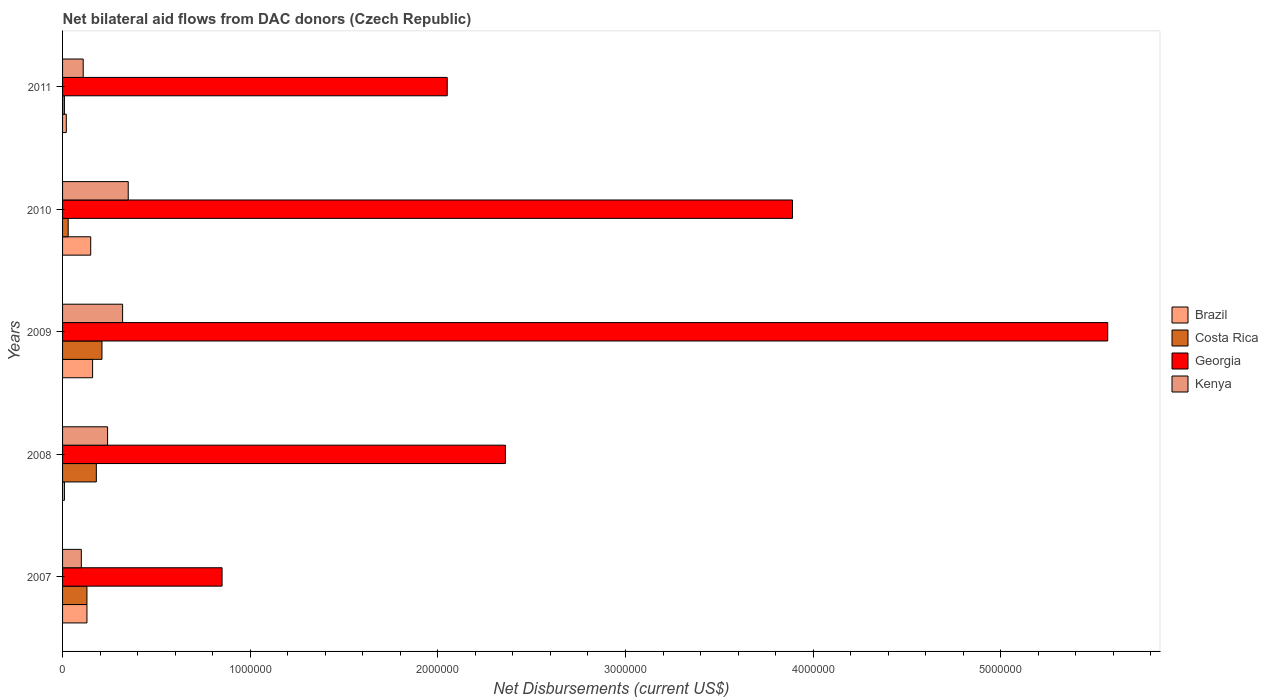Are the number of bars per tick equal to the number of legend labels?
Provide a short and direct response. Yes. Are the number of bars on each tick of the Y-axis equal?
Provide a succinct answer. Yes. How many bars are there on the 2nd tick from the top?
Offer a very short reply. 4. How many bars are there on the 3rd tick from the bottom?
Give a very brief answer. 4. What is the label of the 1st group of bars from the top?
Provide a succinct answer. 2011. In how many cases, is the number of bars for a given year not equal to the number of legend labels?
Your answer should be compact. 0. What is the net bilateral aid flows in Costa Rica in 2010?
Offer a very short reply. 3.00e+04. Across all years, what is the maximum net bilateral aid flows in Costa Rica?
Keep it short and to the point. 2.10e+05. Across all years, what is the minimum net bilateral aid flows in Kenya?
Your response must be concise. 1.00e+05. In which year was the net bilateral aid flows in Costa Rica maximum?
Your answer should be compact. 2009. In which year was the net bilateral aid flows in Georgia minimum?
Ensure brevity in your answer.  2007. What is the total net bilateral aid flows in Georgia in the graph?
Give a very brief answer. 1.47e+07. What is the difference between the net bilateral aid flows in Costa Rica in 2010 and the net bilateral aid flows in Georgia in 2009?
Offer a terse response. -5.54e+06. What is the average net bilateral aid flows in Brazil per year?
Provide a succinct answer. 9.40e+04. In how many years, is the net bilateral aid flows in Georgia greater than 1400000 US$?
Provide a short and direct response. 4. What is the ratio of the net bilateral aid flows in Kenya in 2007 to that in 2010?
Give a very brief answer. 0.29. Is the net bilateral aid flows in Costa Rica in 2007 less than that in 2009?
Ensure brevity in your answer.  Yes. What is the difference between the highest and the second highest net bilateral aid flows in Costa Rica?
Offer a terse response. 3.00e+04. What is the difference between the highest and the lowest net bilateral aid flows in Kenya?
Offer a terse response. 2.50e+05. Is the sum of the net bilateral aid flows in Kenya in 2008 and 2009 greater than the maximum net bilateral aid flows in Brazil across all years?
Your answer should be compact. Yes. Is it the case that in every year, the sum of the net bilateral aid flows in Costa Rica and net bilateral aid flows in Georgia is greater than the sum of net bilateral aid flows in Brazil and net bilateral aid flows in Kenya?
Give a very brief answer. Yes. Is it the case that in every year, the sum of the net bilateral aid flows in Brazil and net bilateral aid flows in Georgia is greater than the net bilateral aid flows in Costa Rica?
Offer a terse response. Yes. How many years are there in the graph?
Offer a very short reply. 5. Does the graph contain any zero values?
Ensure brevity in your answer.  No. Where does the legend appear in the graph?
Give a very brief answer. Center right. How many legend labels are there?
Provide a short and direct response. 4. How are the legend labels stacked?
Your answer should be compact. Vertical. What is the title of the graph?
Provide a short and direct response. Net bilateral aid flows from DAC donors (Czech Republic). What is the label or title of the X-axis?
Provide a short and direct response. Net Disbursements (current US$). What is the Net Disbursements (current US$) of Brazil in 2007?
Provide a short and direct response. 1.30e+05. What is the Net Disbursements (current US$) in Costa Rica in 2007?
Ensure brevity in your answer.  1.30e+05. What is the Net Disbursements (current US$) of Georgia in 2007?
Provide a short and direct response. 8.50e+05. What is the Net Disbursements (current US$) of Georgia in 2008?
Provide a short and direct response. 2.36e+06. What is the Net Disbursements (current US$) in Costa Rica in 2009?
Your answer should be very brief. 2.10e+05. What is the Net Disbursements (current US$) of Georgia in 2009?
Your answer should be compact. 5.57e+06. What is the Net Disbursements (current US$) in Kenya in 2009?
Ensure brevity in your answer.  3.20e+05. What is the Net Disbursements (current US$) of Georgia in 2010?
Provide a short and direct response. 3.89e+06. What is the Net Disbursements (current US$) in Georgia in 2011?
Provide a short and direct response. 2.05e+06. Across all years, what is the maximum Net Disbursements (current US$) of Costa Rica?
Your response must be concise. 2.10e+05. Across all years, what is the maximum Net Disbursements (current US$) of Georgia?
Provide a succinct answer. 5.57e+06. Across all years, what is the minimum Net Disbursements (current US$) in Georgia?
Offer a very short reply. 8.50e+05. Across all years, what is the minimum Net Disbursements (current US$) of Kenya?
Your response must be concise. 1.00e+05. What is the total Net Disbursements (current US$) of Brazil in the graph?
Ensure brevity in your answer.  4.70e+05. What is the total Net Disbursements (current US$) in Costa Rica in the graph?
Keep it short and to the point. 5.60e+05. What is the total Net Disbursements (current US$) of Georgia in the graph?
Provide a succinct answer. 1.47e+07. What is the total Net Disbursements (current US$) in Kenya in the graph?
Keep it short and to the point. 1.12e+06. What is the difference between the Net Disbursements (current US$) in Brazil in 2007 and that in 2008?
Offer a very short reply. 1.20e+05. What is the difference between the Net Disbursements (current US$) in Costa Rica in 2007 and that in 2008?
Your answer should be very brief. -5.00e+04. What is the difference between the Net Disbursements (current US$) of Georgia in 2007 and that in 2008?
Offer a very short reply. -1.51e+06. What is the difference between the Net Disbursements (current US$) of Kenya in 2007 and that in 2008?
Offer a very short reply. -1.40e+05. What is the difference between the Net Disbursements (current US$) in Brazil in 2007 and that in 2009?
Your response must be concise. -3.00e+04. What is the difference between the Net Disbursements (current US$) in Costa Rica in 2007 and that in 2009?
Your answer should be very brief. -8.00e+04. What is the difference between the Net Disbursements (current US$) in Georgia in 2007 and that in 2009?
Provide a short and direct response. -4.72e+06. What is the difference between the Net Disbursements (current US$) in Costa Rica in 2007 and that in 2010?
Give a very brief answer. 1.00e+05. What is the difference between the Net Disbursements (current US$) of Georgia in 2007 and that in 2010?
Your answer should be compact. -3.04e+06. What is the difference between the Net Disbursements (current US$) of Brazil in 2007 and that in 2011?
Your answer should be very brief. 1.10e+05. What is the difference between the Net Disbursements (current US$) of Costa Rica in 2007 and that in 2011?
Your answer should be very brief. 1.20e+05. What is the difference between the Net Disbursements (current US$) in Georgia in 2007 and that in 2011?
Offer a very short reply. -1.20e+06. What is the difference between the Net Disbursements (current US$) of Kenya in 2007 and that in 2011?
Make the answer very short. -10000. What is the difference between the Net Disbursements (current US$) of Brazil in 2008 and that in 2009?
Provide a short and direct response. -1.50e+05. What is the difference between the Net Disbursements (current US$) in Georgia in 2008 and that in 2009?
Provide a short and direct response. -3.21e+06. What is the difference between the Net Disbursements (current US$) of Brazil in 2008 and that in 2010?
Give a very brief answer. -1.40e+05. What is the difference between the Net Disbursements (current US$) in Costa Rica in 2008 and that in 2010?
Provide a short and direct response. 1.50e+05. What is the difference between the Net Disbursements (current US$) in Georgia in 2008 and that in 2010?
Your answer should be compact. -1.53e+06. What is the difference between the Net Disbursements (current US$) of Kenya in 2008 and that in 2010?
Offer a very short reply. -1.10e+05. What is the difference between the Net Disbursements (current US$) of Georgia in 2008 and that in 2011?
Offer a very short reply. 3.10e+05. What is the difference between the Net Disbursements (current US$) in Georgia in 2009 and that in 2010?
Provide a succinct answer. 1.68e+06. What is the difference between the Net Disbursements (current US$) in Brazil in 2009 and that in 2011?
Your answer should be compact. 1.40e+05. What is the difference between the Net Disbursements (current US$) of Georgia in 2009 and that in 2011?
Provide a short and direct response. 3.52e+06. What is the difference between the Net Disbursements (current US$) of Georgia in 2010 and that in 2011?
Your answer should be very brief. 1.84e+06. What is the difference between the Net Disbursements (current US$) of Brazil in 2007 and the Net Disbursements (current US$) of Costa Rica in 2008?
Ensure brevity in your answer.  -5.00e+04. What is the difference between the Net Disbursements (current US$) of Brazil in 2007 and the Net Disbursements (current US$) of Georgia in 2008?
Make the answer very short. -2.23e+06. What is the difference between the Net Disbursements (current US$) of Costa Rica in 2007 and the Net Disbursements (current US$) of Georgia in 2008?
Make the answer very short. -2.23e+06. What is the difference between the Net Disbursements (current US$) in Costa Rica in 2007 and the Net Disbursements (current US$) in Kenya in 2008?
Your answer should be very brief. -1.10e+05. What is the difference between the Net Disbursements (current US$) in Georgia in 2007 and the Net Disbursements (current US$) in Kenya in 2008?
Offer a terse response. 6.10e+05. What is the difference between the Net Disbursements (current US$) in Brazil in 2007 and the Net Disbursements (current US$) in Costa Rica in 2009?
Keep it short and to the point. -8.00e+04. What is the difference between the Net Disbursements (current US$) in Brazil in 2007 and the Net Disbursements (current US$) in Georgia in 2009?
Your response must be concise. -5.44e+06. What is the difference between the Net Disbursements (current US$) in Brazil in 2007 and the Net Disbursements (current US$) in Kenya in 2009?
Offer a terse response. -1.90e+05. What is the difference between the Net Disbursements (current US$) in Costa Rica in 2007 and the Net Disbursements (current US$) in Georgia in 2009?
Ensure brevity in your answer.  -5.44e+06. What is the difference between the Net Disbursements (current US$) of Costa Rica in 2007 and the Net Disbursements (current US$) of Kenya in 2009?
Ensure brevity in your answer.  -1.90e+05. What is the difference between the Net Disbursements (current US$) of Georgia in 2007 and the Net Disbursements (current US$) of Kenya in 2009?
Provide a short and direct response. 5.30e+05. What is the difference between the Net Disbursements (current US$) of Brazil in 2007 and the Net Disbursements (current US$) of Georgia in 2010?
Keep it short and to the point. -3.76e+06. What is the difference between the Net Disbursements (current US$) in Brazil in 2007 and the Net Disbursements (current US$) in Kenya in 2010?
Provide a short and direct response. -2.20e+05. What is the difference between the Net Disbursements (current US$) in Costa Rica in 2007 and the Net Disbursements (current US$) in Georgia in 2010?
Your answer should be very brief. -3.76e+06. What is the difference between the Net Disbursements (current US$) of Brazil in 2007 and the Net Disbursements (current US$) of Costa Rica in 2011?
Your answer should be very brief. 1.20e+05. What is the difference between the Net Disbursements (current US$) in Brazil in 2007 and the Net Disbursements (current US$) in Georgia in 2011?
Offer a very short reply. -1.92e+06. What is the difference between the Net Disbursements (current US$) in Brazil in 2007 and the Net Disbursements (current US$) in Kenya in 2011?
Ensure brevity in your answer.  2.00e+04. What is the difference between the Net Disbursements (current US$) of Costa Rica in 2007 and the Net Disbursements (current US$) of Georgia in 2011?
Your response must be concise. -1.92e+06. What is the difference between the Net Disbursements (current US$) in Costa Rica in 2007 and the Net Disbursements (current US$) in Kenya in 2011?
Provide a succinct answer. 2.00e+04. What is the difference between the Net Disbursements (current US$) in Georgia in 2007 and the Net Disbursements (current US$) in Kenya in 2011?
Ensure brevity in your answer.  7.40e+05. What is the difference between the Net Disbursements (current US$) of Brazil in 2008 and the Net Disbursements (current US$) of Costa Rica in 2009?
Offer a very short reply. -2.00e+05. What is the difference between the Net Disbursements (current US$) of Brazil in 2008 and the Net Disbursements (current US$) of Georgia in 2009?
Ensure brevity in your answer.  -5.56e+06. What is the difference between the Net Disbursements (current US$) of Brazil in 2008 and the Net Disbursements (current US$) of Kenya in 2009?
Your answer should be compact. -3.10e+05. What is the difference between the Net Disbursements (current US$) of Costa Rica in 2008 and the Net Disbursements (current US$) of Georgia in 2009?
Offer a terse response. -5.39e+06. What is the difference between the Net Disbursements (current US$) in Costa Rica in 2008 and the Net Disbursements (current US$) in Kenya in 2009?
Your answer should be compact. -1.40e+05. What is the difference between the Net Disbursements (current US$) of Georgia in 2008 and the Net Disbursements (current US$) of Kenya in 2009?
Provide a short and direct response. 2.04e+06. What is the difference between the Net Disbursements (current US$) of Brazil in 2008 and the Net Disbursements (current US$) of Costa Rica in 2010?
Your response must be concise. -2.00e+04. What is the difference between the Net Disbursements (current US$) of Brazil in 2008 and the Net Disbursements (current US$) of Georgia in 2010?
Offer a terse response. -3.88e+06. What is the difference between the Net Disbursements (current US$) in Costa Rica in 2008 and the Net Disbursements (current US$) in Georgia in 2010?
Your answer should be very brief. -3.71e+06. What is the difference between the Net Disbursements (current US$) of Costa Rica in 2008 and the Net Disbursements (current US$) of Kenya in 2010?
Ensure brevity in your answer.  -1.70e+05. What is the difference between the Net Disbursements (current US$) of Georgia in 2008 and the Net Disbursements (current US$) of Kenya in 2010?
Make the answer very short. 2.01e+06. What is the difference between the Net Disbursements (current US$) of Brazil in 2008 and the Net Disbursements (current US$) of Georgia in 2011?
Your response must be concise. -2.04e+06. What is the difference between the Net Disbursements (current US$) in Costa Rica in 2008 and the Net Disbursements (current US$) in Georgia in 2011?
Your response must be concise. -1.87e+06. What is the difference between the Net Disbursements (current US$) of Georgia in 2008 and the Net Disbursements (current US$) of Kenya in 2011?
Offer a terse response. 2.25e+06. What is the difference between the Net Disbursements (current US$) in Brazil in 2009 and the Net Disbursements (current US$) in Costa Rica in 2010?
Make the answer very short. 1.30e+05. What is the difference between the Net Disbursements (current US$) in Brazil in 2009 and the Net Disbursements (current US$) in Georgia in 2010?
Give a very brief answer. -3.73e+06. What is the difference between the Net Disbursements (current US$) in Costa Rica in 2009 and the Net Disbursements (current US$) in Georgia in 2010?
Provide a succinct answer. -3.68e+06. What is the difference between the Net Disbursements (current US$) in Georgia in 2009 and the Net Disbursements (current US$) in Kenya in 2010?
Ensure brevity in your answer.  5.22e+06. What is the difference between the Net Disbursements (current US$) of Brazil in 2009 and the Net Disbursements (current US$) of Costa Rica in 2011?
Keep it short and to the point. 1.50e+05. What is the difference between the Net Disbursements (current US$) of Brazil in 2009 and the Net Disbursements (current US$) of Georgia in 2011?
Offer a very short reply. -1.89e+06. What is the difference between the Net Disbursements (current US$) of Costa Rica in 2009 and the Net Disbursements (current US$) of Georgia in 2011?
Offer a very short reply. -1.84e+06. What is the difference between the Net Disbursements (current US$) of Costa Rica in 2009 and the Net Disbursements (current US$) of Kenya in 2011?
Offer a terse response. 1.00e+05. What is the difference between the Net Disbursements (current US$) of Georgia in 2009 and the Net Disbursements (current US$) of Kenya in 2011?
Provide a short and direct response. 5.46e+06. What is the difference between the Net Disbursements (current US$) in Brazil in 2010 and the Net Disbursements (current US$) in Costa Rica in 2011?
Give a very brief answer. 1.40e+05. What is the difference between the Net Disbursements (current US$) in Brazil in 2010 and the Net Disbursements (current US$) in Georgia in 2011?
Give a very brief answer. -1.90e+06. What is the difference between the Net Disbursements (current US$) in Costa Rica in 2010 and the Net Disbursements (current US$) in Georgia in 2011?
Give a very brief answer. -2.02e+06. What is the difference between the Net Disbursements (current US$) of Georgia in 2010 and the Net Disbursements (current US$) of Kenya in 2011?
Offer a terse response. 3.78e+06. What is the average Net Disbursements (current US$) in Brazil per year?
Your answer should be very brief. 9.40e+04. What is the average Net Disbursements (current US$) in Costa Rica per year?
Keep it short and to the point. 1.12e+05. What is the average Net Disbursements (current US$) in Georgia per year?
Provide a short and direct response. 2.94e+06. What is the average Net Disbursements (current US$) in Kenya per year?
Your answer should be very brief. 2.24e+05. In the year 2007, what is the difference between the Net Disbursements (current US$) in Brazil and Net Disbursements (current US$) in Costa Rica?
Provide a short and direct response. 0. In the year 2007, what is the difference between the Net Disbursements (current US$) in Brazil and Net Disbursements (current US$) in Georgia?
Offer a very short reply. -7.20e+05. In the year 2007, what is the difference between the Net Disbursements (current US$) in Costa Rica and Net Disbursements (current US$) in Georgia?
Ensure brevity in your answer.  -7.20e+05. In the year 2007, what is the difference between the Net Disbursements (current US$) of Georgia and Net Disbursements (current US$) of Kenya?
Offer a very short reply. 7.50e+05. In the year 2008, what is the difference between the Net Disbursements (current US$) in Brazil and Net Disbursements (current US$) in Georgia?
Offer a very short reply. -2.35e+06. In the year 2008, what is the difference between the Net Disbursements (current US$) of Brazil and Net Disbursements (current US$) of Kenya?
Keep it short and to the point. -2.30e+05. In the year 2008, what is the difference between the Net Disbursements (current US$) of Costa Rica and Net Disbursements (current US$) of Georgia?
Your answer should be compact. -2.18e+06. In the year 2008, what is the difference between the Net Disbursements (current US$) of Georgia and Net Disbursements (current US$) of Kenya?
Provide a succinct answer. 2.12e+06. In the year 2009, what is the difference between the Net Disbursements (current US$) in Brazil and Net Disbursements (current US$) in Georgia?
Keep it short and to the point. -5.41e+06. In the year 2009, what is the difference between the Net Disbursements (current US$) in Brazil and Net Disbursements (current US$) in Kenya?
Your response must be concise. -1.60e+05. In the year 2009, what is the difference between the Net Disbursements (current US$) in Costa Rica and Net Disbursements (current US$) in Georgia?
Your answer should be compact. -5.36e+06. In the year 2009, what is the difference between the Net Disbursements (current US$) in Georgia and Net Disbursements (current US$) in Kenya?
Make the answer very short. 5.25e+06. In the year 2010, what is the difference between the Net Disbursements (current US$) of Brazil and Net Disbursements (current US$) of Georgia?
Provide a succinct answer. -3.74e+06. In the year 2010, what is the difference between the Net Disbursements (current US$) in Brazil and Net Disbursements (current US$) in Kenya?
Ensure brevity in your answer.  -2.00e+05. In the year 2010, what is the difference between the Net Disbursements (current US$) of Costa Rica and Net Disbursements (current US$) of Georgia?
Offer a terse response. -3.86e+06. In the year 2010, what is the difference between the Net Disbursements (current US$) of Costa Rica and Net Disbursements (current US$) of Kenya?
Offer a terse response. -3.20e+05. In the year 2010, what is the difference between the Net Disbursements (current US$) of Georgia and Net Disbursements (current US$) of Kenya?
Offer a very short reply. 3.54e+06. In the year 2011, what is the difference between the Net Disbursements (current US$) of Brazil and Net Disbursements (current US$) of Costa Rica?
Provide a succinct answer. 10000. In the year 2011, what is the difference between the Net Disbursements (current US$) of Brazil and Net Disbursements (current US$) of Georgia?
Provide a succinct answer. -2.03e+06. In the year 2011, what is the difference between the Net Disbursements (current US$) in Brazil and Net Disbursements (current US$) in Kenya?
Your answer should be very brief. -9.00e+04. In the year 2011, what is the difference between the Net Disbursements (current US$) of Costa Rica and Net Disbursements (current US$) of Georgia?
Ensure brevity in your answer.  -2.04e+06. In the year 2011, what is the difference between the Net Disbursements (current US$) of Costa Rica and Net Disbursements (current US$) of Kenya?
Keep it short and to the point. -1.00e+05. In the year 2011, what is the difference between the Net Disbursements (current US$) of Georgia and Net Disbursements (current US$) of Kenya?
Keep it short and to the point. 1.94e+06. What is the ratio of the Net Disbursements (current US$) of Costa Rica in 2007 to that in 2008?
Keep it short and to the point. 0.72. What is the ratio of the Net Disbursements (current US$) in Georgia in 2007 to that in 2008?
Your response must be concise. 0.36. What is the ratio of the Net Disbursements (current US$) of Kenya in 2007 to that in 2008?
Make the answer very short. 0.42. What is the ratio of the Net Disbursements (current US$) of Brazil in 2007 to that in 2009?
Offer a very short reply. 0.81. What is the ratio of the Net Disbursements (current US$) in Costa Rica in 2007 to that in 2009?
Ensure brevity in your answer.  0.62. What is the ratio of the Net Disbursements (current US$) in Georgia in 2007 to that in 2009?
Offer a terse response. 0.15. What is the ratio of the Net Disbursements (current US$) of Kenya in 2007 to that in 2009?
Give a very brief answer. 0.31. What is the ratio of the Net Disbursements (current US$) in Brazil in 2007 to that in 2010?
Your response must be concise. 0.87. What is the ratio of the Net Disbursements (current US$) of Costa Rica in 2007 to that in 2010?
Make the answer very short. 4.33. What is the ratio of the Net Disbursements (current US$) of Georgia in 2007 to that in 2010?
Provide a succinct answer. 0.22. What is the ratio of the Net Disbursements (current US$) in Kenya in 2007 to that in 2010?
Keep it short and to the point. 0.29. What is the ratio of the Net Disbursements (current US$) of Georgia in 2007 to that in 2011?
Ensure brevity in your answer.  0.41. What is the ratio of the Net Disbursements (current US$) of Brazil in 2008 to that in 2009?
Keep it short and to the point. 0.06. What is the ratio of the Net Disbursements (current US$) of Georgia in 2008 to that in 2009?
Provide a short and direct response. 0.42. What is the ratio of the Net Disbursements (current US$) of Kenya in 2008 to that in 2009?
Offer a very short reply. 0.75. What is the ratio of the Net Disbursements (current US$) in Brazil in 2008 to that in 2010?
Ensure brevity in your answer.  0.07. What is the ratio of the Net Disbursements (current US$) of Costa Rica in 2008 to that in 2010?
Your answer should be compact. 6. What is the ratio of the Net Disbursements (current US$) of Georgia in 2008 to that in 2010?
Your answer should be compact. 0.61. What is the ratio of the Net Disbursements (current US$) in Kenya in 2008 to that in 2010?
Give a very brief answer. 0.69. What is the ratio of the Net Disbursements (current US$) of Brazil in 2008 to that in 2011?
Your answer should be compact. 0.5. What is the ratio of the Net Disbursements (current US$) of Georgia in 2008 to that in 2011?
Ensure brevity in your answer.  1.15. What is the ratio of the Net Disbursements (current US$) of Kenya in 2008 to that in 2011?
Make the answer very short. 2.18. What is the ratio of the Net Disbursements (current US$) of Brazil in 2009 to that in 2010?
Make the answer very short. 1.07. What is the ratio of the Net Disbursements (current US$) in Georgia in 2009 to that in 2010?
Your response must be concise. 1.43. What is the ratio of the Net Disbursements (current US$) of Kenya in 2009 to that in 2010?
Ensure brevity in your answer.  0.91. What is the ratio of the Net Disbursements (current US$) of Brazil in 2009 to that in 2011?
Provide a short and direct response. 8. What is the ratio of the Net Disbursements (current US$) of Georgia in 2009 to that in 2011?
Ensure brevity in your answer.  2.72. What is the ratio of the Net Disbursements (current US$) in Kenya in 2009 to that in 2011?
Provide a succinct answer. 2.91. What is the ratio of the Net Disbursements (current US$) of Costa Rica in 2010 to that in 2011?
Offer a terse response. 3. What is the ratio of the Net Disbursements (current US$) in Georgia in 2010 to that in 2011?
Offer a very short reply. 1.9. What is the ratio of the Net Disbursements (current US$) of Kenya in 2010 to that in 2011?
Your answer should be very brief. 3.18. What is the difference between the highest and the second highest Net Disbursements (current US$) in Brazil?
Keep it short and to the point. 10000. What is the difference between the highest and the second highest Net Disbursements (current US$) in Costa Rica?
Make the answer very short. 3.00e+04. What is the difference between the highest and the second highest Net Disbursements (current US$) of Georgia?
Your response must be concise. 1.68e+06. What is the difference between the highest and the second highest Net Disbursements (current US$) in Kenya?
Offer a terse response. 3.00e+04. What is the difference between the highest and the lowest Net Disbursements (current US$) in Georgia?
Ensure brevity in your answer.  4.72e+06. What is the difference between the highest and the lowest Net Disbursements (current US$) of Kenya?
Provide a succinct answer. 2.50e+05. 